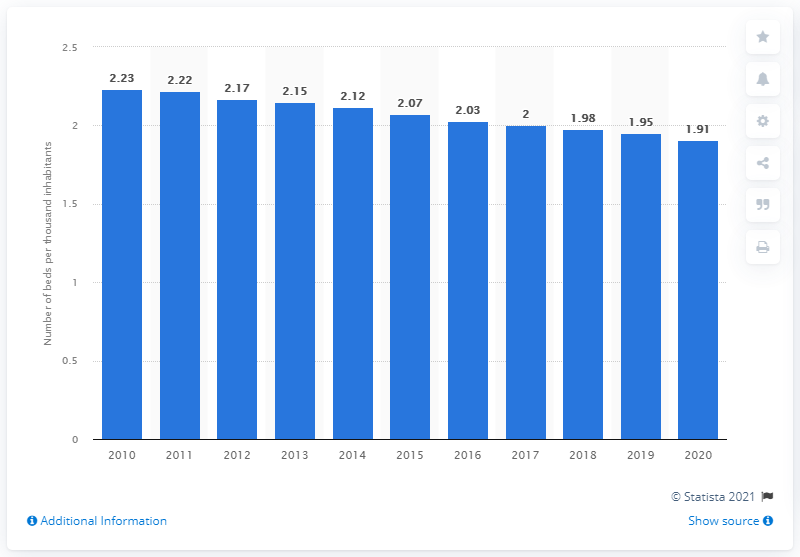Give some essential details in this illustration. In Brazil in 2020, there were 1.91 hospital beds per thousand inhabitants. 